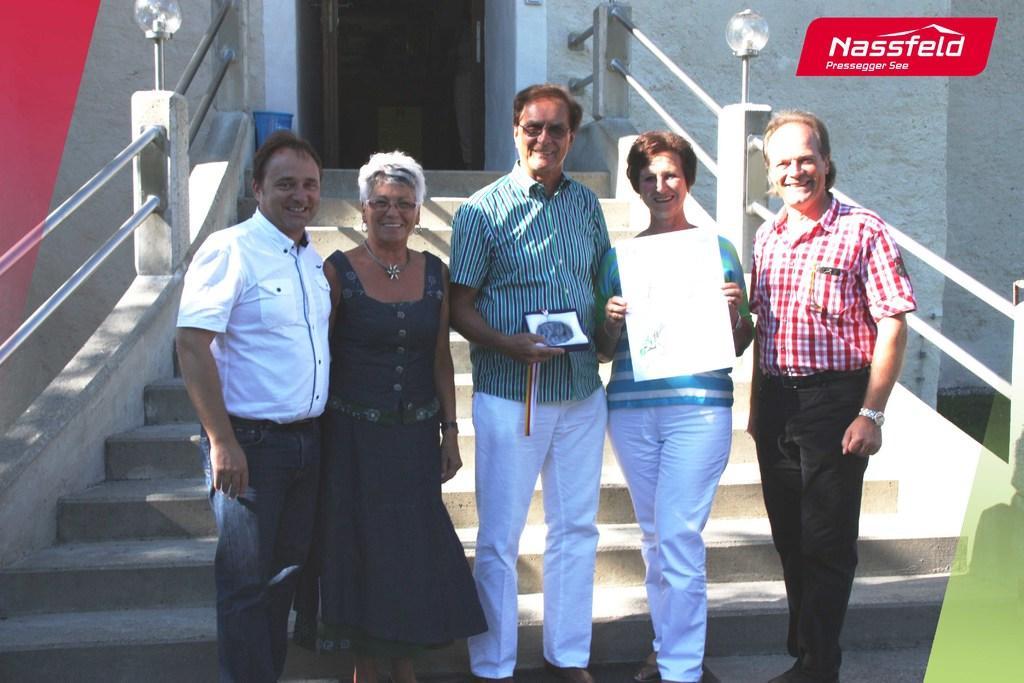Please provide a concise description of this image. In this picture there are people those who are standing in the center of the image, on stairs and there is a staircase in the center of the image, there is a door at the top side of the image, there is a lady who is standing on the right side of the image, by holding a paper in her hands. 